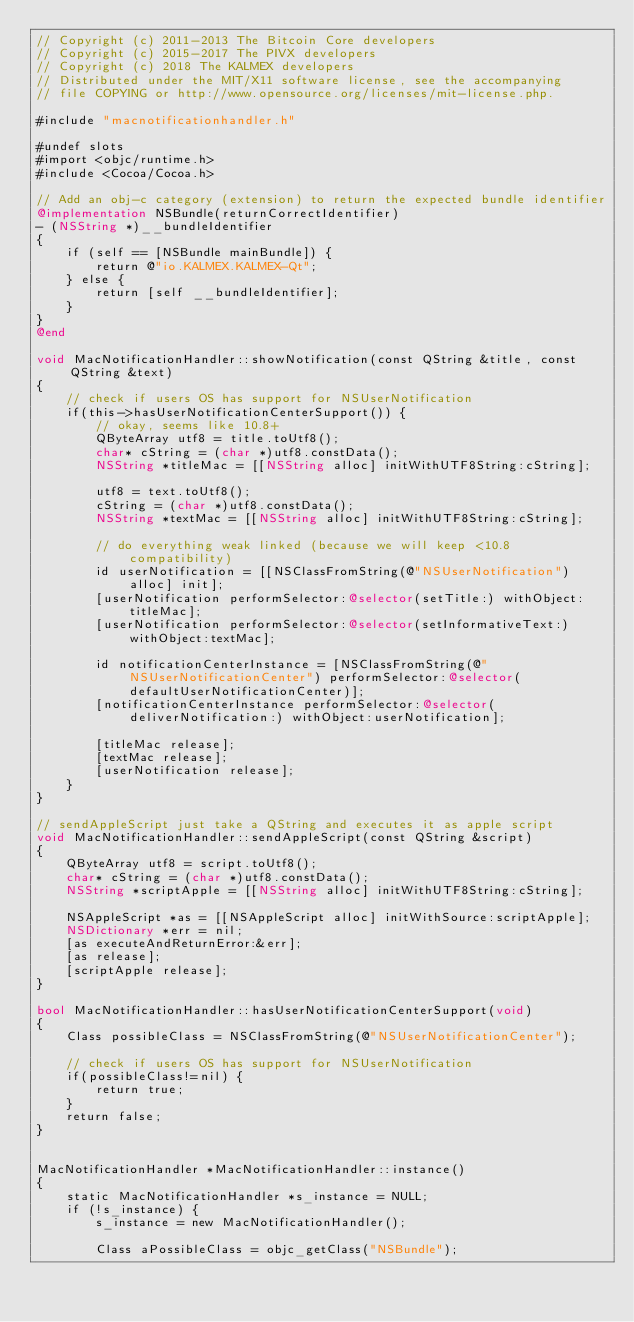<code> <loc_0><loc_0><loc_500><loc_500><_ObjectiveC_>// Copyright (c) 2011-2013 The Bitcoin Core developers
// Copyright (c) 2015-2017 The PIVX developers 
// Copyright (c) 2018 The KALMEX developers
// Distributed under the MIT/X11 software license, see the accompanying
// file COPYING or http://www.opensource.org/licenses/mit-license.php.

#include "macnotificationhandler.h"

#undef slots
#import <objc/runtime.h>
#include <Cocoa/Cocoa.h>

// Add an obj-c category (extension) to return the expected bundle identifier
@implementation NSBundle(returnCorrectIdentifier)
- (NSString *)__bundleIdentifier
{
    if (self == [NSBundle mainBundle]) {
        return @"io.KALMEX.KALMEX-Qt";
    } else {
        return [self __bundleIdentifier];
    }
}
@end

void MacNotificationHandler::showNotification(const QString &title, const QString &text)
{
    // check if users OS has support for NSUserNotification
    if(this->hasUserNotificationCenterSupport()) {
        // okay, seems like 10.8+
        QByteArray utf8 = title.toUtf8();
        char* cString = (char *)utf8.constData();
        NSString *titleMac = [[NSString alloc] initWithUTF8String:cString];

        utf8 = text.toUtf8();
        cString = (char *)utf8.constData();
        NSString *textMac = [[NSString alloc] initWithUTF8String:cString];

        // do everything weak linked (because we will keep <10.8 compatibility)
        id userNotification = [[NSClassFromString(@"NSUserNotification") alloc] init];
        [userNotification performSelector:@selector(setTitle:) withObject:titleMac];
        [userNotification performSelector:@selector(setInformativeText:) withObject:textMac];

        id notificationCenterInstance = [NSClassFromString(@"NSUserNotificationCenter") performSelector:@selector(defaultUserNotificationCenter)];
        [notificationCenterInstance performSelector:@selector(deliverNotification:) withObject:userNotification];

        [titleMac release];
        [textMac release];
        [userNotification release];
    }
}

// sendAppleScript just take a QString and executes it as apple script
void MacNotificationHandler::sendAppleScript(const QString &script)
{
    QByteArray utf8 = script.toUtf8();
    char* cString = (char *)utf8.constData();
    NSString *scriptApple = [[NSString alloc] initWithUTF8String:cString];

    NSAppleScript *as = [[NSAppleScript alloc] initWithSource:scriptApple];
    NSDictionary *err = nil;
    [as executeAndReturnError:&err];
    [as release];
    [scriptApple release];
}

bool MacNotificationHandler::hasUserNotificationCenterSupport(void)
{
    Class possibleClass = NSClassFromString(@"NSUserNotificationCenter");

    // check if users OS has support for NSUserNotification
    if(possibleClass!=nil) {
        return true;
    }
    return false;
}


MacNotificationHandler *MacNotificationHandler::instance()
{
    static MacNotificationHandler *s_instance = NULL;
    if (!s_instance) {
        s_instance = new MacNotificationHandler();
        
        Class aPossibleClass = objc_getClass("NSBundle");</code> 